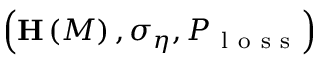<formula> <loc_0><loc_0><loc_500><loc_500>\left ( H \left ( M \right ) , \sigma _ { \eta } , P _ { l o s s } \right )</formula> 